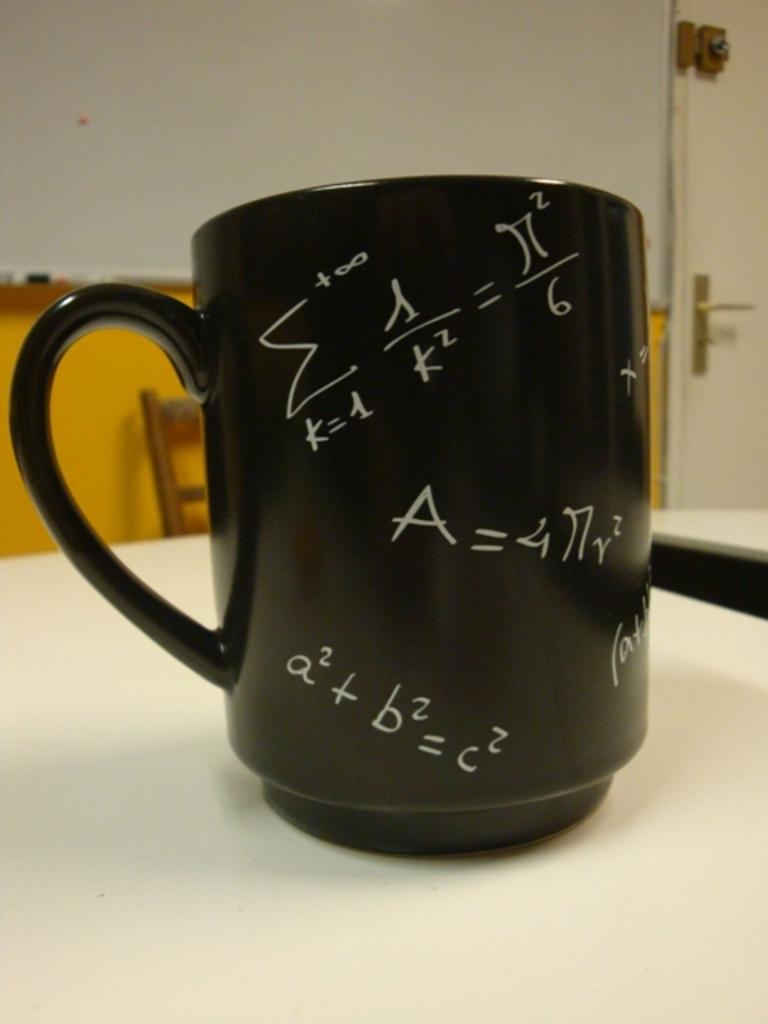<image>
Render a clear and concise summary of the photo. The cup shown contains may mathmatical equations including a2 